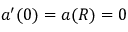Convert formula to latex. <formula><loc_0><loc_0><loc_500><loc_500>a ^ { \prime } ( 0 ) = a ( R ) = 0</formula> 